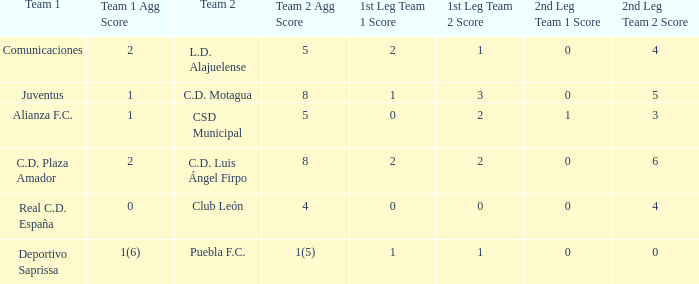What is the 1st leg where Team 1 is C.D. Plaza Amador? 2 - 2. 